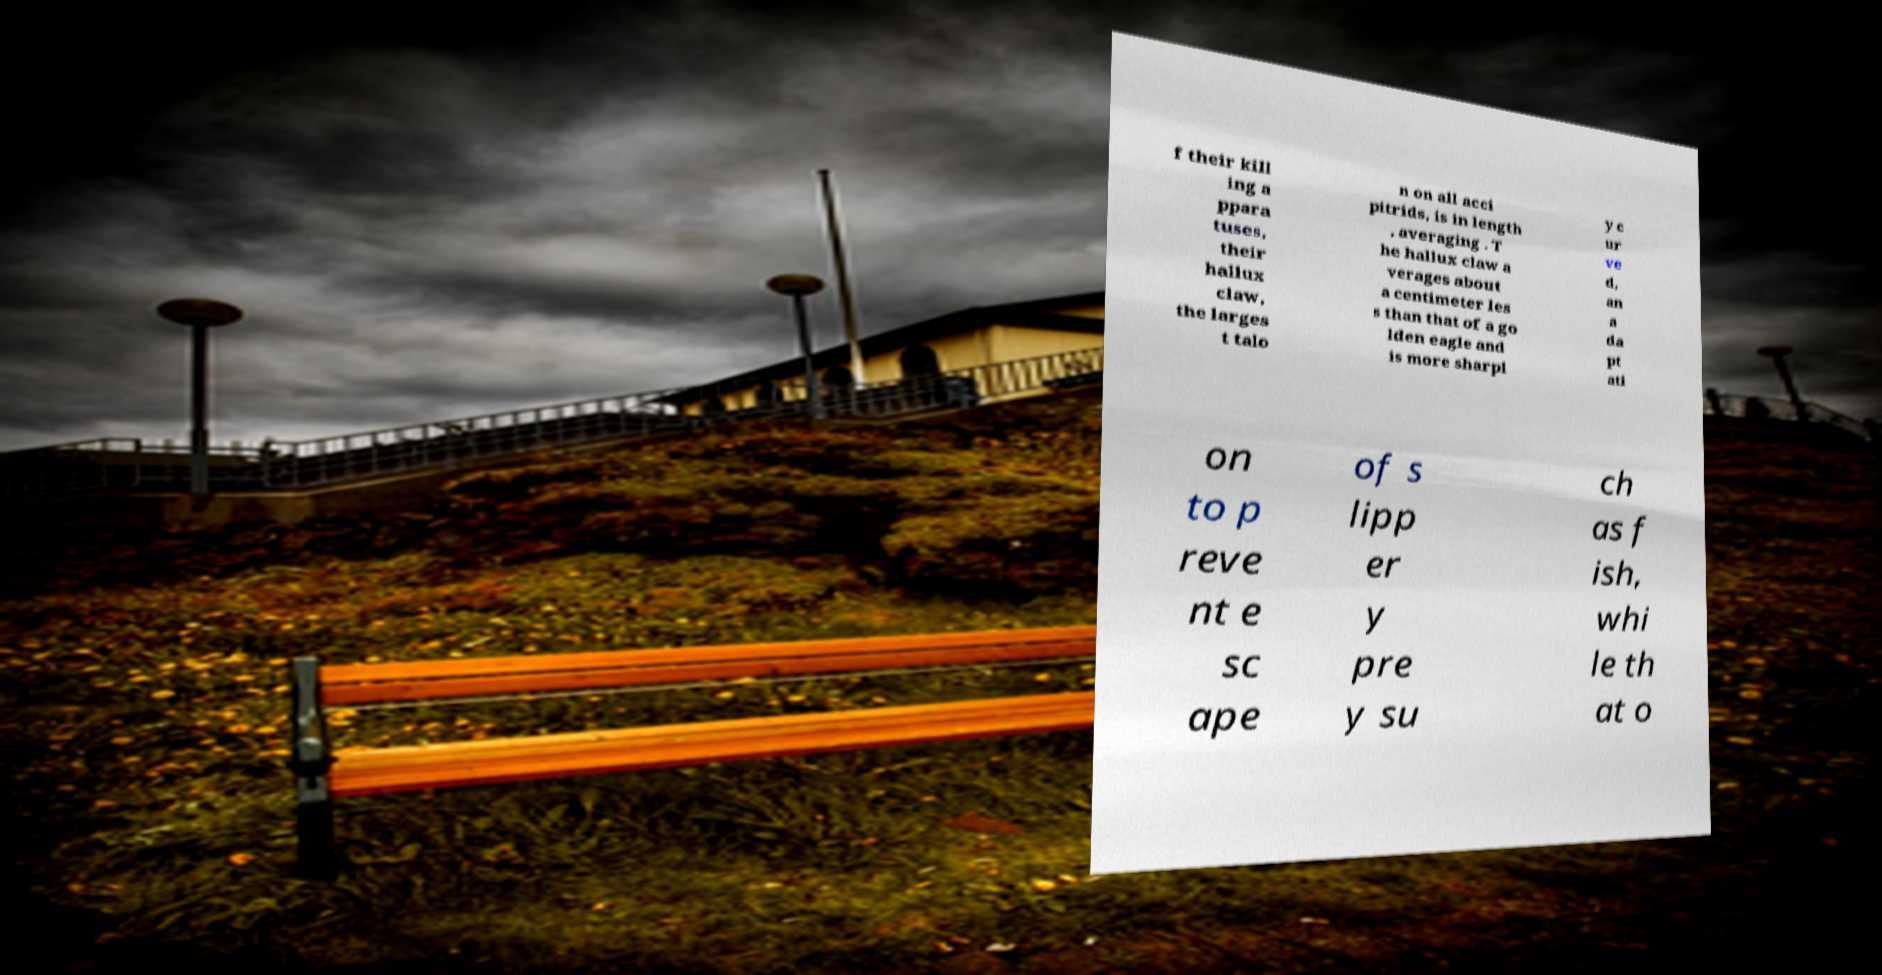For documentation purposes, I need the text within this image transcribed. Could you provide that? f their kill ing a ppara tuses, their hallux claw, the larges t talo n on all acci pitrids, is in length , averaging . T he hallux claw a verages about a centimeter les s than that of a go lden eagle and is more sharpl y c ur ve d, an a da pt ati on to p reve nt e sc ape of s lipp er y pre y su ch as f ish, whi le th at o 